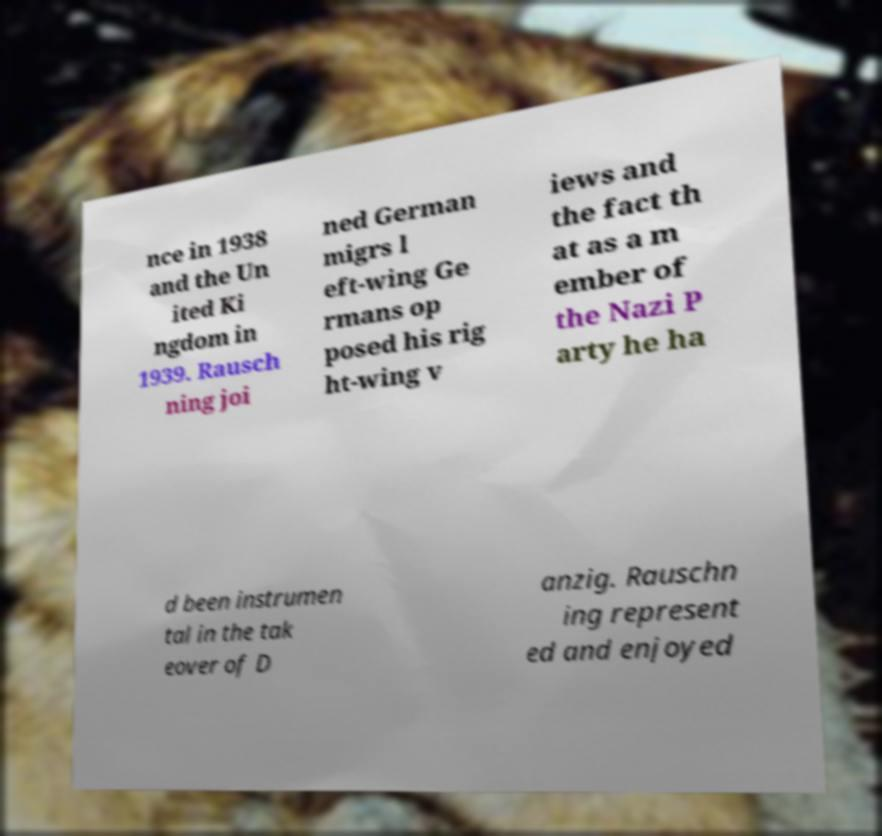Can you accurately transcribe the text from the provided image for me? nce in 1938 and the Un ited Ki ngdom in 1939. Rausch ning joi ned German migrs l eft-wing Ge rmans op posed his rig ht-wing v iews and the fact th at as a m ember of the Nazi P arty he ha d been instrumen tal in the tak eover of D anzig. Rauschn ing represent ed and enjoyed 